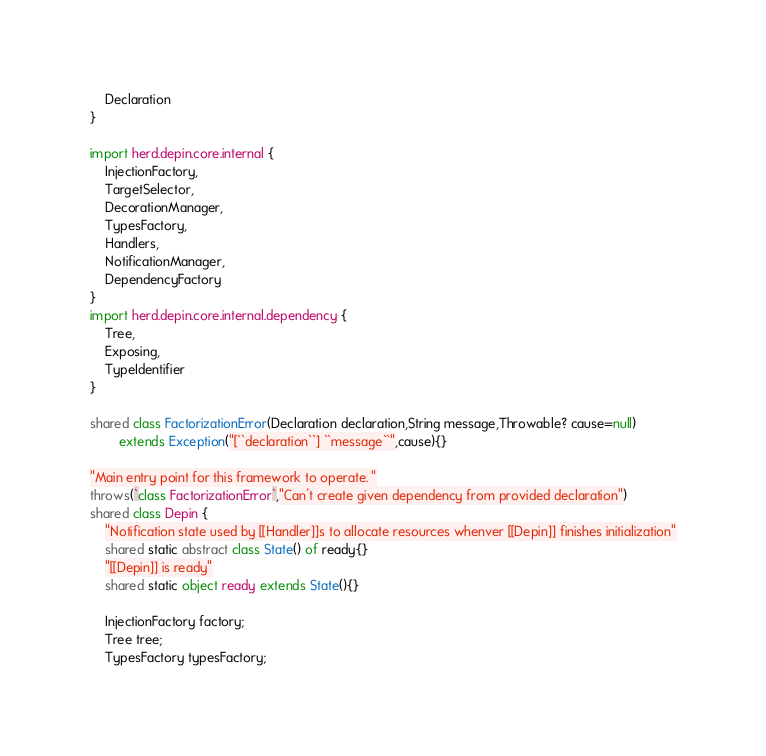Convert code to text. <code><loc_0><loc_0><loc_500><loc_500><_Ceylon_>	Declaration
}

import herd.depin.core.internal {
	InjectionFactory,
	TargetSelector,
	DecorationManager,
	TypesFactory,
	Handlers,
	NotificationManager,
	DependencyFactory
}
import herd.depin.core.internal.dependency {
	Tree,
	Exposing,
	TypeIdentifier
}

shared class FactorizationError(Declaration declaration,String message,Throwable? cause=null) 
		extends Exception("[``declaration``] ``message``",cause){}

"Main entry point for this framework to operate. "
throws(`class FactorizationError`,"Can't create given dependency from provided declaration")
shared class Depin {
	"Notification state used by [[Handler]]s to allocate resources whenver [[Depin]] finishes initialization"
	shared static abstract class State() of ready{}
	"[[Depin]] is ready"
	shared static object ready extends State(){}

	InjectionFactory factory;
	Tree tree;
	TypesFactory typesFactory;</code> 